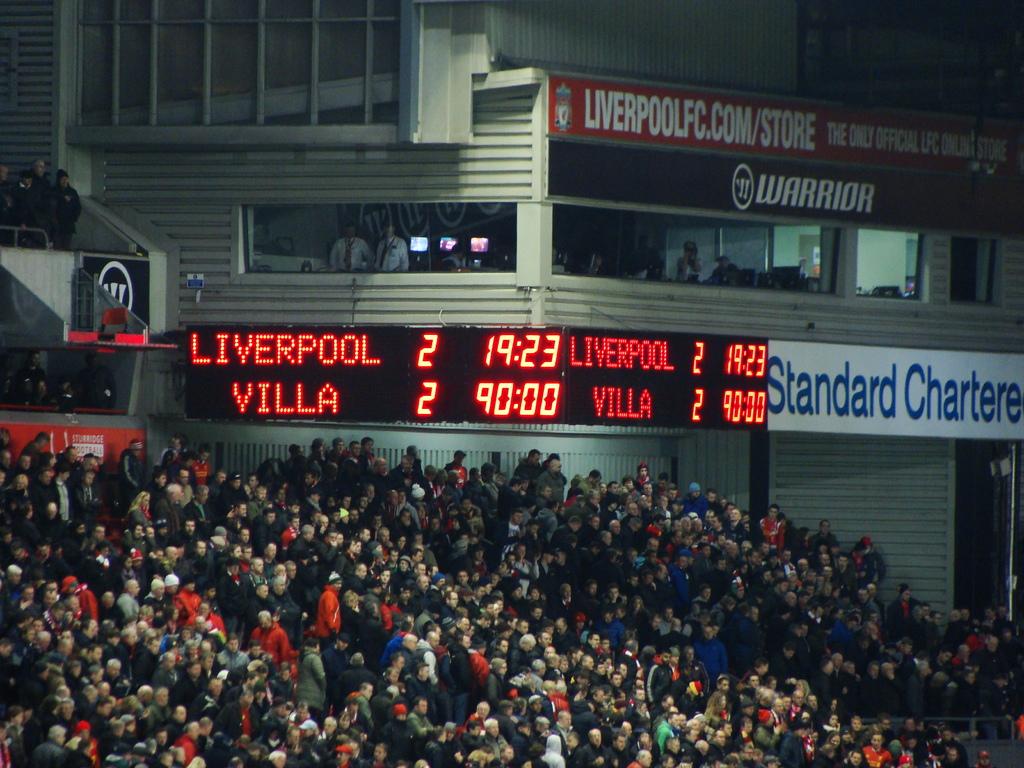How many goals did liverpool score?
Provide a succinct answer. 2. How many goals did villa score?
Ensure brevity in your answer.  2. 